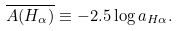<formula> <loc_0><loc_0><loc_500><loc_500>\overline { A ( H _ { \alpha } ) } \equiv - 2 . 5 \log { a _ { H \alpha } } .</formula> 